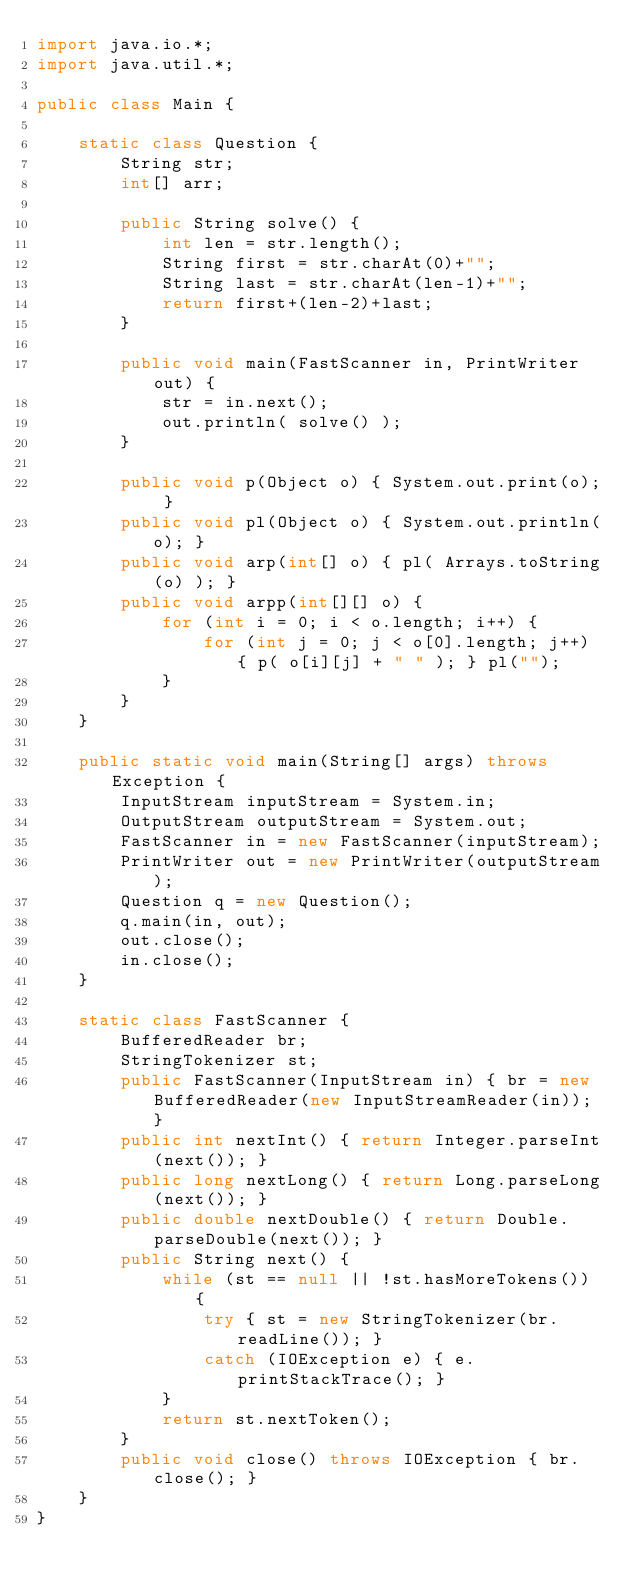<code> <loc_0><loc_0><loc_500><loc_500><_Java_>import java.io.*;
import java.util.*;

public class Main {

    static class Question {
        String str;
        int[] arr;
        
        public String solve() {
            int len = str.length();
            String first = str.charAt(0)+"";
            String last = str.charAt(len-1)+"";
            return first+(len-2)+last;
        }
        
        public void main(FastScanner in, PrintWriter out) {
            str = in.next();
            out.println( solve() );
        }
        
        public void p(Object o) { System.out.print(o); }
        public void pl(Object o) { System.out.println(o); }
        public void arp(int[] o) { pl( Arrays.toString(o) ); }
        public void arpp(int[][] o) { 
            for (int i = 0; i < o.length; i++) {
                for (int j = 0; j < o[0].length; j++) { p( o[i][j] + " " ); } pl("");
            }
        }
    }

    public static void main(String[] args) throws Exception {
        InputStream inputStream = System.in;
        OutputStream outputStream = System.out;
        FastScanner in = new FastScanner(inputStream);
        PrintWriter out = new PrintWriter(outputStream);
        Question q = new Question();
        q.main(in, out);
        out.close();
        in.close();
    }
    
    static class FastScanner {
        BufferedReader br;
        StringTokenizer st;
        public FastScanner(InputStream in) { br = new BufferedReader(new InputStreamReader(in)); }
        public int nextInt() { return Integer.parseInt(next()); }
        public long nextLong() { return Long.parseLong(next()); }
        public double nextDouble() { return Double.parseDouble(next()); }
        public String next() {
            while (st == null || !st.hasMoreTokens()) {
                try { st = new StringTokenizer(br.readLine()); } 
                catch (IOException e) { e.printStackTrace(); }
            }
            return st.nextToken();
        }
        public void close() throws IOException { br.close(); }
    }
}</code> 